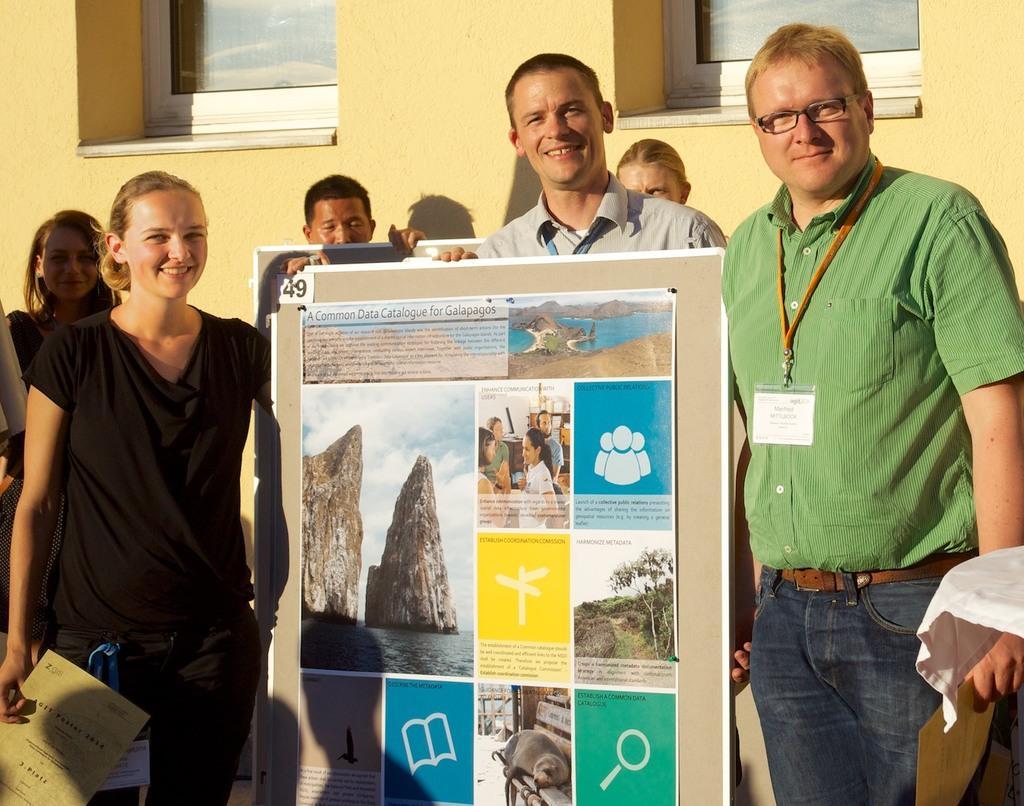Describe this image in one or two sentences. In this image in front there are few people standing by holding the boards. Behind them there is a wall with the glass windows. 